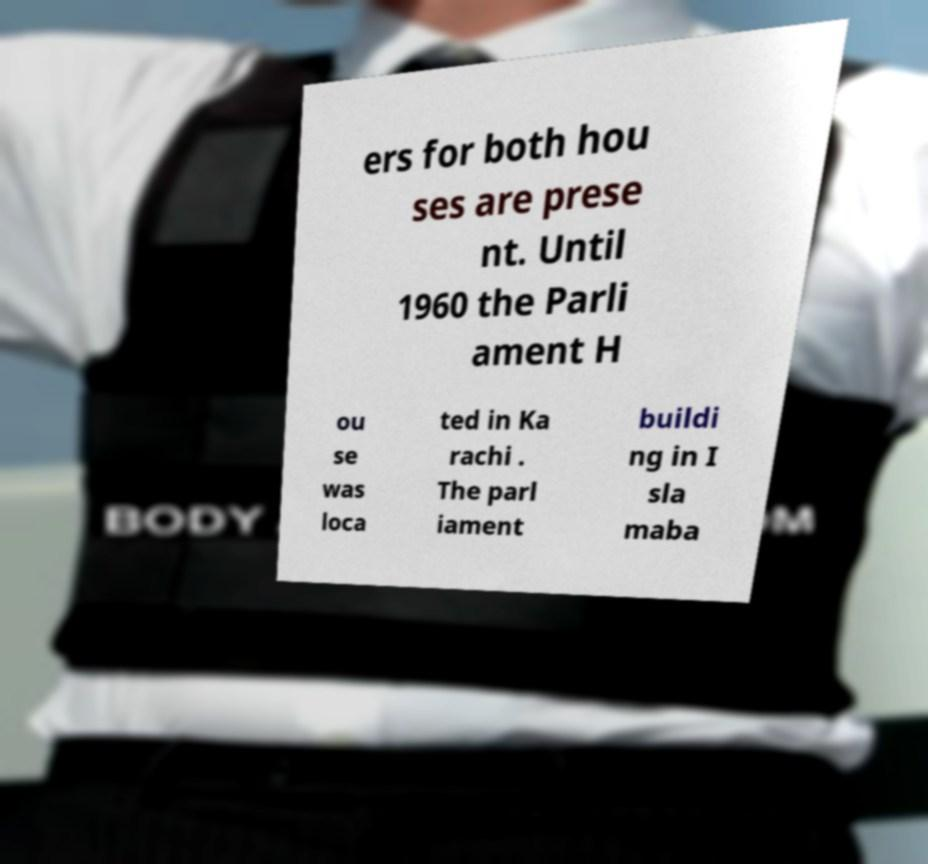Please read and relay the text visible in this image. What does it say? ers for both hou ses are prese nt. Until 1960 the Parli ament H ou se was loca ted in Ka rachi . The parl iament buildi ng in I sla maba 